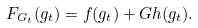<formula> <loc_0><loc_0><loc_500><loc_500>F _ { G _ { t } } ( g _ { t } ) = f ( g _ { t } ) + G h ( g _ { t } ) .</formula> 